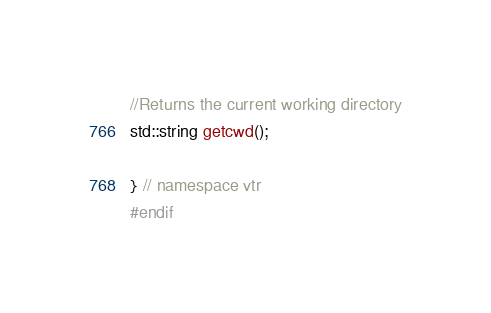<code> <loc_0><loc_0><loc_500><loc_500><_C_>//Returns the current working directory
std::string getcwd();

} // namespace vtr
#endif
</code> 